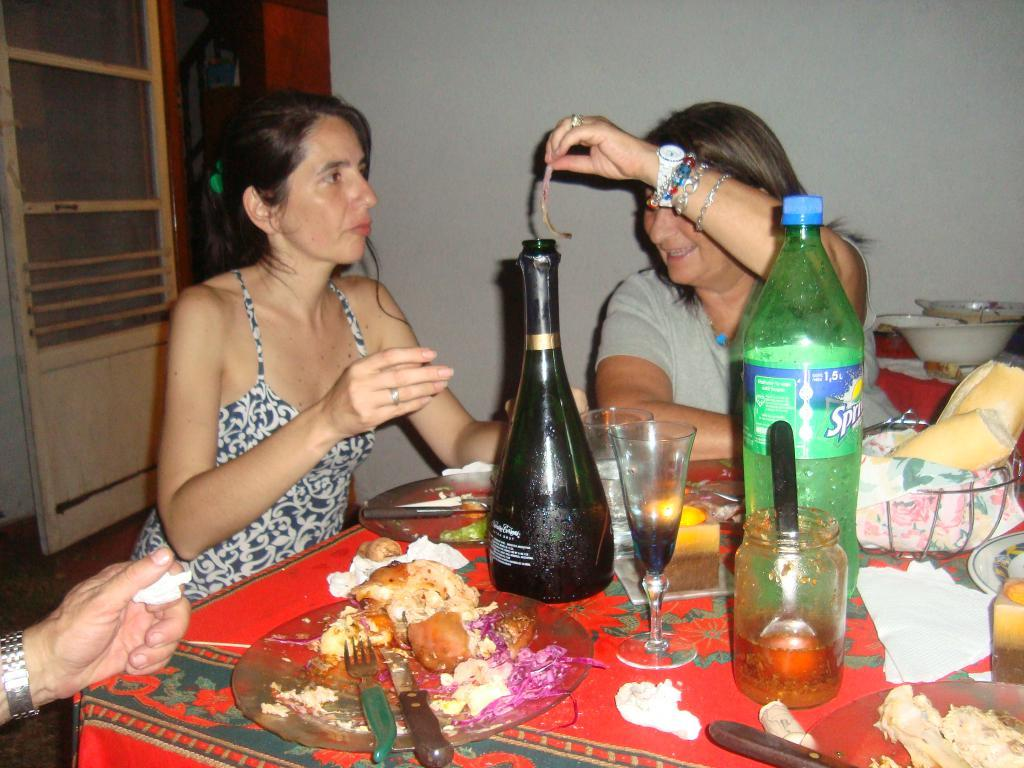<image>
Create a compact narrative representing the image presented. Two women sitting at a table with a glass bottle and a bottle of Sprite in front of them. 